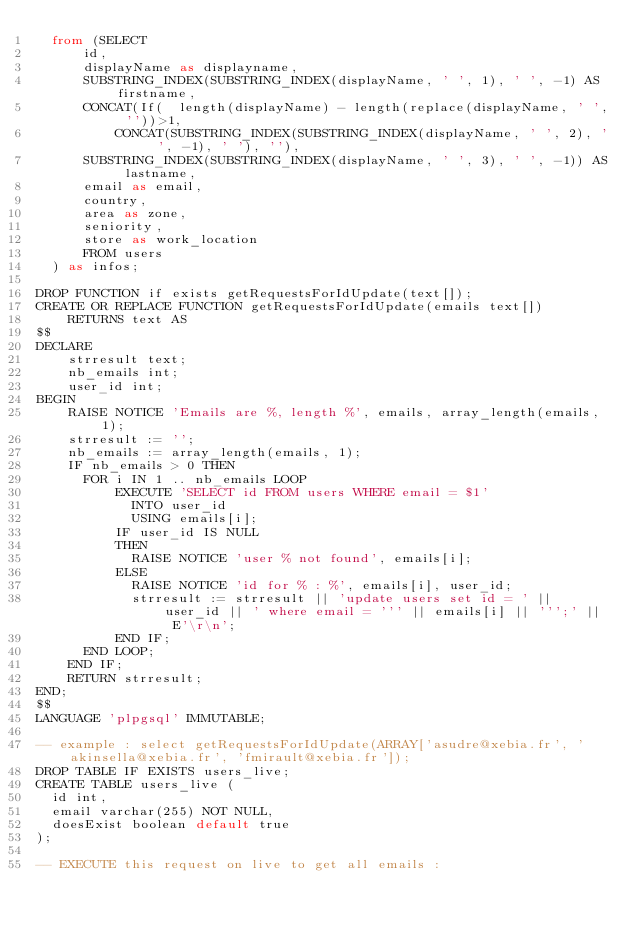<code> <loc_0><loc_0><loc_500><loc_500><_SQL_>  from (SELECT
      id,
      displayName as displayname,
      SUBSTRING_INDEX(SUBSTRING_INDEX(displayName, ' ', 1), ' ', -1) AS firstname,
      CONCAT(If(  length(displayName) - length(replace(displayName, ' ', ''))>1,
		  CONCAT(SUBSTRING_INDEX(SUBSTRING_INDEX(displayName, ' ', 2), ' ', -1), ' '), ''),
      SUBSTRING_INDEX(SUBSTRING_INDEX(displayName, ' ', 3), ' ', -1)) AS lastname,
      email as email,
      country,
      area as zone,
      seniority,
      store as work_location
      FROM users
  ) as infos;

DROP FUNCTION if exists getRequestsForIdUpdate(text[]);
CREATE OR REPLACE FUNCTION getRequestsForIdUpdate(emails text[])
    RETURNS text AS
$$
DECLARE
    strresult text;
    nb_emails int;
    user_id int;
BEGIN
    RAISE NOTICE 'Emails are %, length %', emails, array_length(emails, 1);
    strresult := '';
    nb_emails := array_length(emails, 1);
    IF nb_emails > 0 THEN
      FOR i IN 1 .. nb_emails LOOP
	      EXECUTE 'SELECT id FROM users WHERE email = $1'
		    INTO user_id
		    USING emails[i];
	      IF user_id IS NULL
	      THEN
	        RAISE NOTICE 'user % not found', emails[i];
	      ELSE
	        RAISE NOTICE 'id for % : %', emails[i], user_id;
	        strresult := strresult || 'update users set id = ' || user_id || ' where email = ''' || emails[i] || ''';' || E'\r\n';
	      END IF;
      END LOOP;
    END IF;
    RETURN strresult;
END;
$$
LANGUAGE 'plpgsql' IMMUTABLE;

-- example : select getRequestsForIdUpdate(ARRAY['asudre@xebia.fr', 'akinsella@xebia.fr', 'fmirault@xebia.fr']);
DROP TABLE IF EXISTS users_live;
CREATE TABLE users_live (
  id int,
  email varchar(255) NOT NULL,
  doesExist boolean default true
);

-- EXECUTE this request on live to get all emails :</code> 